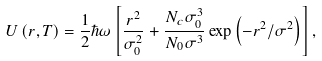<formula> <loc_0><loc_0><loc_500><loc_500>U \left ( r , T \right ) = \frac { 1 } { 2 } \hbar { \omega } \left [ \frac { r ^ { 2 } } { \sigma _ { 0 } ^ { 2 } } + \frac { N _ { c } \sigma _ { 0 } ^ { 3 } } { N _ { 0 } \sigma ^ { 3 } } \exp \left ( - r ^ { 2 } / \sigma ^ { 2 } \right ) \right ] ,</formula> 